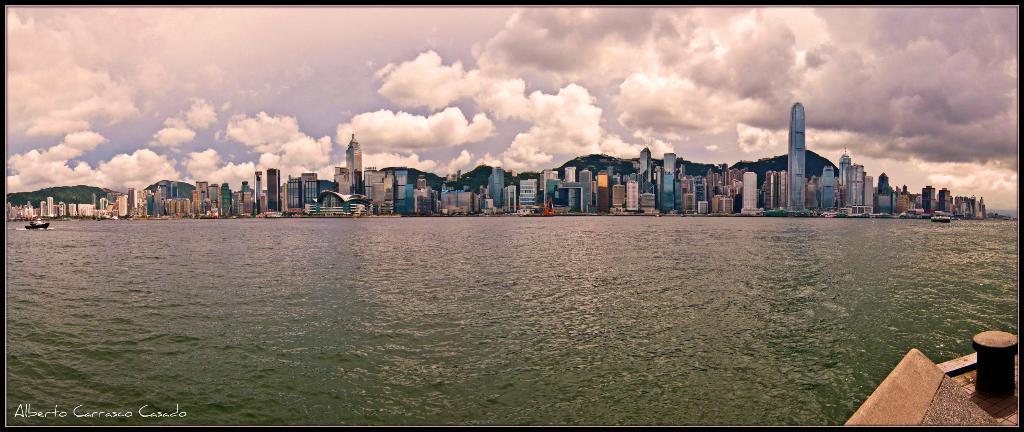In one or two sentences, can you explain what this image depicts? In this picture we can see boats on the water, buildings and hills. In the background of the image we can see the sky. In the bottom left side of the image we can see text. In the bottom right side of the image we can see an object. 